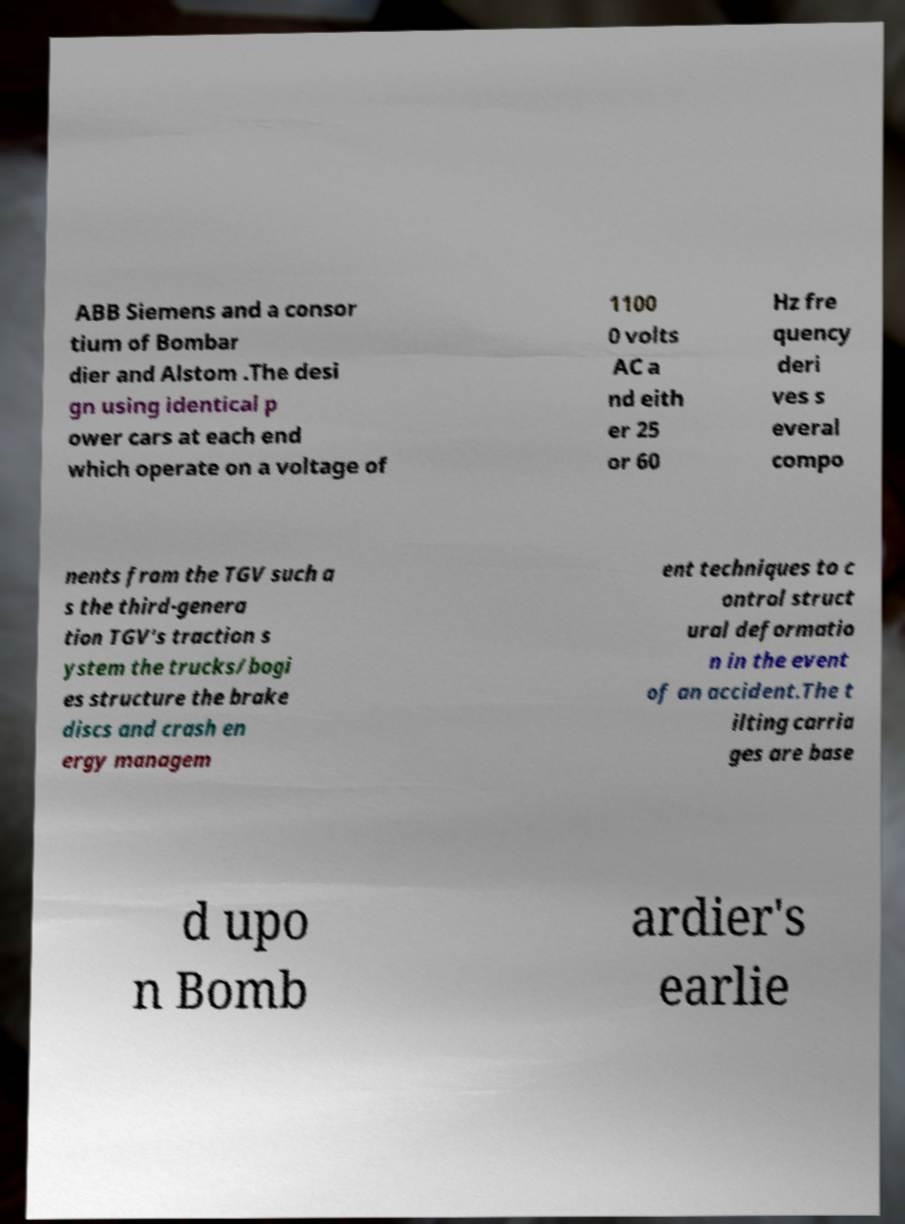Could you extract and type out the text from this image? ABB Siemens and a consor tium of Bombar dier and Alstom .The desi gn using identical p ower cars at each end which operate on a voltage of 1100 0 volts AC a nd eith er 25 or 60 Hz fre quency deri ves s everal compo nents from the TGV such a s the third-genera tion TGV's traction s ystem the trucks/bogi es structure the brake discs and crash en ergy managem ent techniques to c ontrol struct ural deformatio n in the event of an accident.The t ilting carria ges are base d upo n Bomb ardier's earlie 